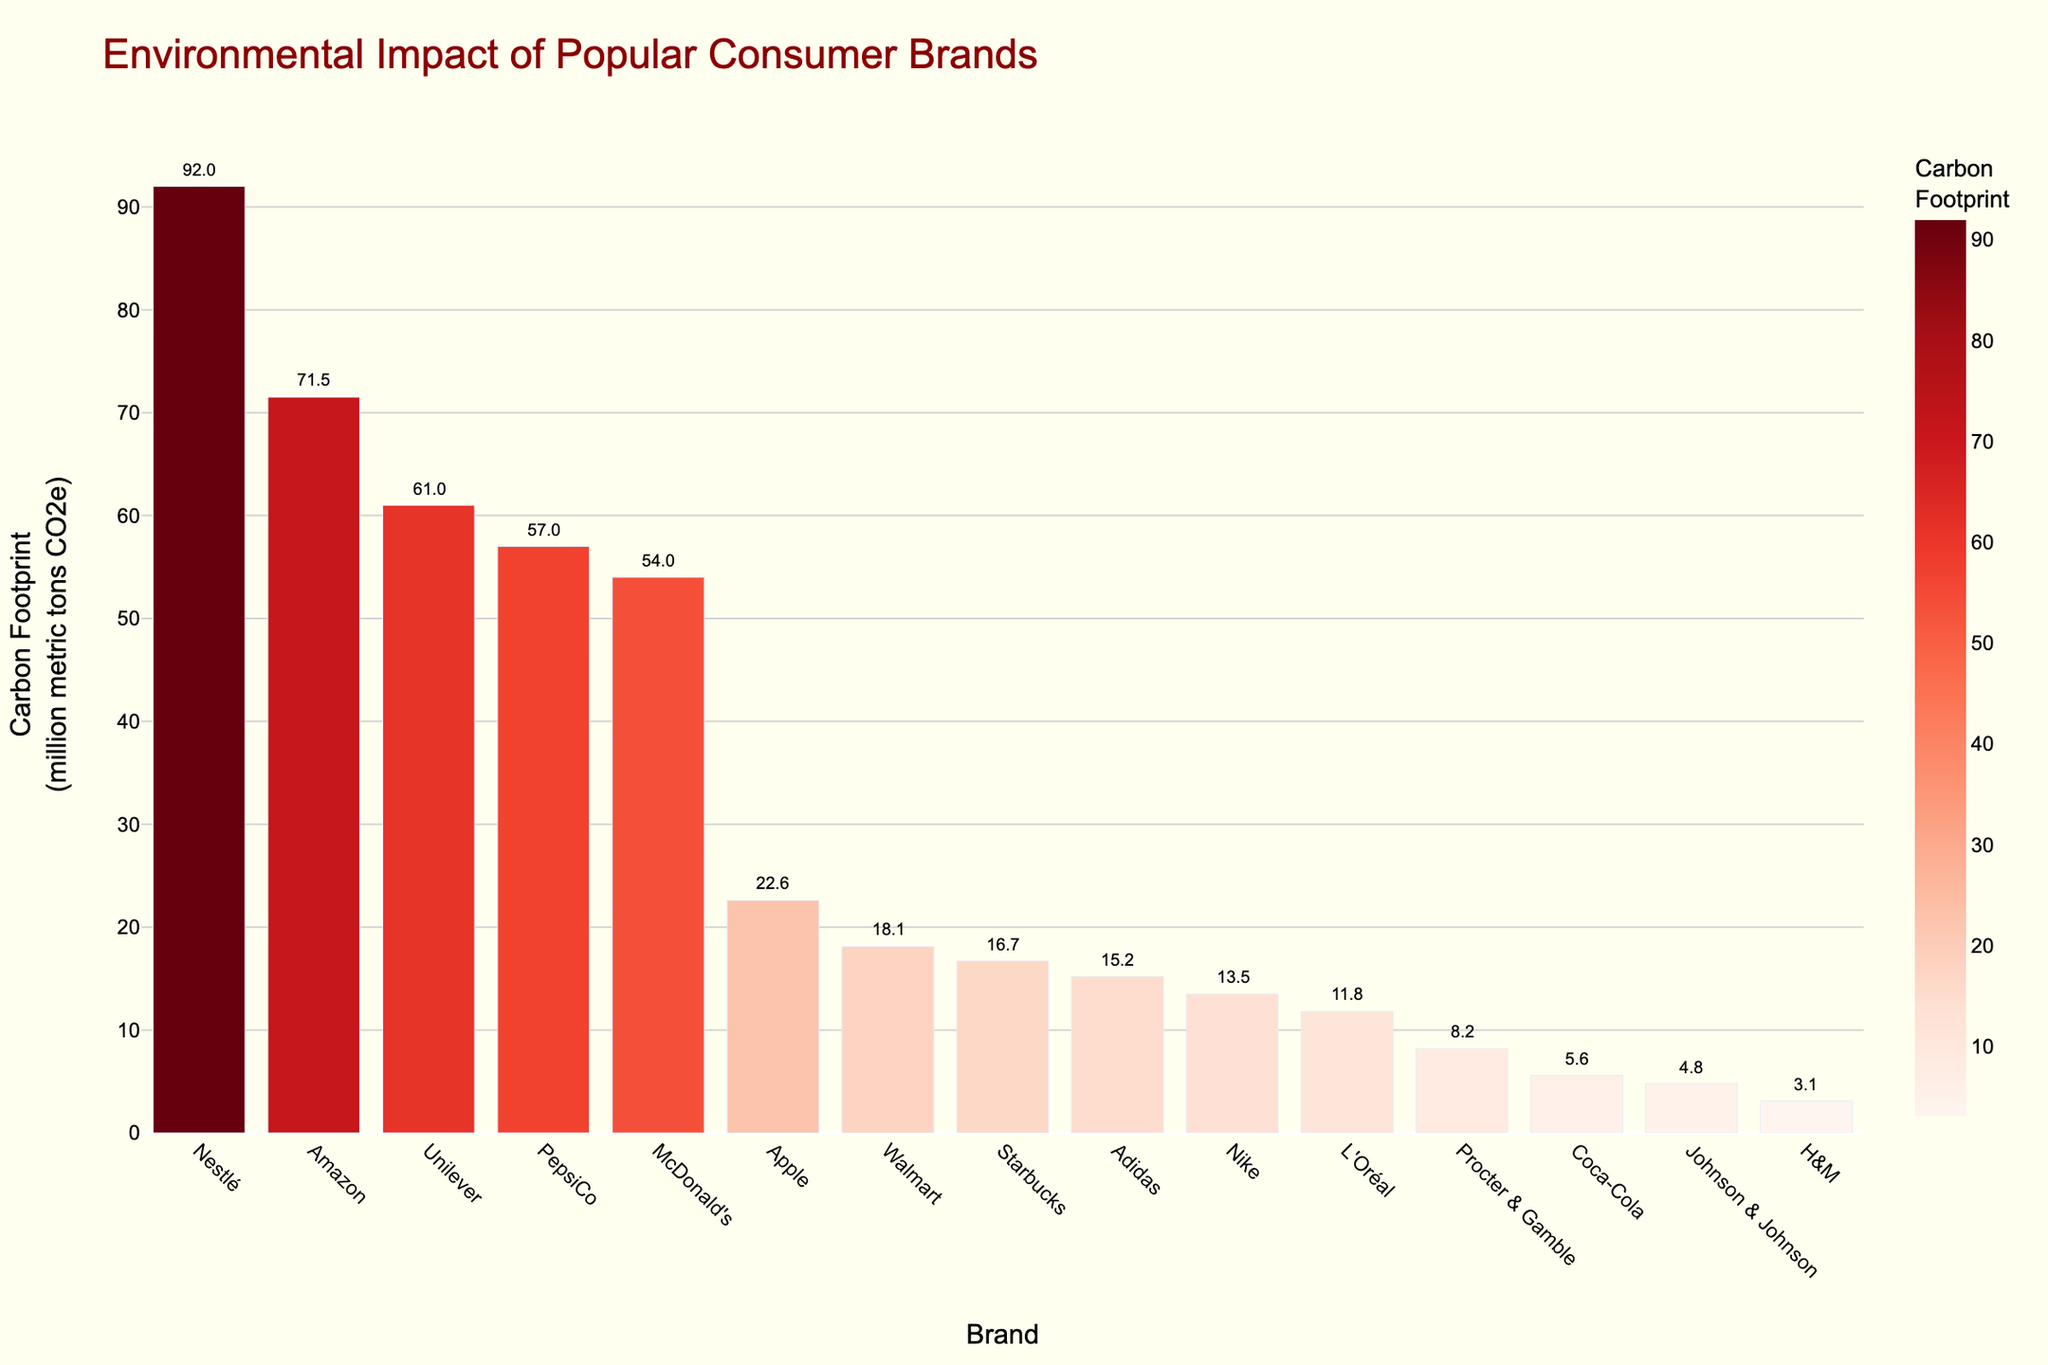Which brand has the highest carbon footprint? The highest bar represents Nestlé with a carbon footprint of 92.0 million metric tons CO2e.
Answer: Nestlé Which brand has the smallest carbon footprint? The smallest bar represents H&M with a carbon footprint of 3.1 million metric tons CO2e.
Answer: H&M How does Amazon's carbon footprint compare to Unilever's? Amazon's carbon footprint is 71.5 million metric tons CO2e, while Unilever's is 61.0 million metric tons CO2e. Amazon's is higher by 10.5 million metric tons CO2e.
Answer: Amazon's is higher What is the combined carbon footprint of Nike and Adidas? Nike's carbon footprint is 13.5 and Adidas's is 15.2. Combined, they total 13.5 + 15.2 = 28.7 million metric tons CO2e.
Answer: 28.7 million metric tons CO2e Which brand has a carbon footprint closest to 10 million metric tons CO2e? L'Oréal has a carbon footprint of 11.8 million metric tons CO2e, which is the closest to 10 million metric tons CO2e among the brands.
Answer: L'Oréal What is the average carbon footprint of McDonald's, PepsiCo, and Starbucks? Summing their carbon footprints: McDonald's (54.0) + PepsiCo (57.0) + Starbucks (16.7) = 127.7. Dividing by 3 gives an average of 127.7 / 3 ≈ 42.6 million metric tons CO2e.
Answer: 42.6 million metric tons CO2e By how much does Walmart's carbon footprint exceed that of Johnson & Johnson? Walmart's carbon footprint is 18.1 and Johnson & Johnson's is 4.8. The difference is 18.1 - 4.8 = 13.3 million metric tons CO2e.
Answer: 13.3 million metric tons CO2e What is the ratio of Apple's carbon footprint to Coca-Cola's? Apple's carbon footprint is 22.6 and Coca-Cola's is 5.6. The ratio is 22.6 / 5.6 ≈ 4.04.
Answer: 4.04 Which brands have a carbon footprint greater than 50 million metric tons CO2e? Brands with bars taller than 50 on the y-axis are Nestlé (92.0), Amazon (71.5), McDonald's (54.0), and PepsiCo (57.0).
Answer: Nestlé, Amazon, McDonald's, PepsiCo 